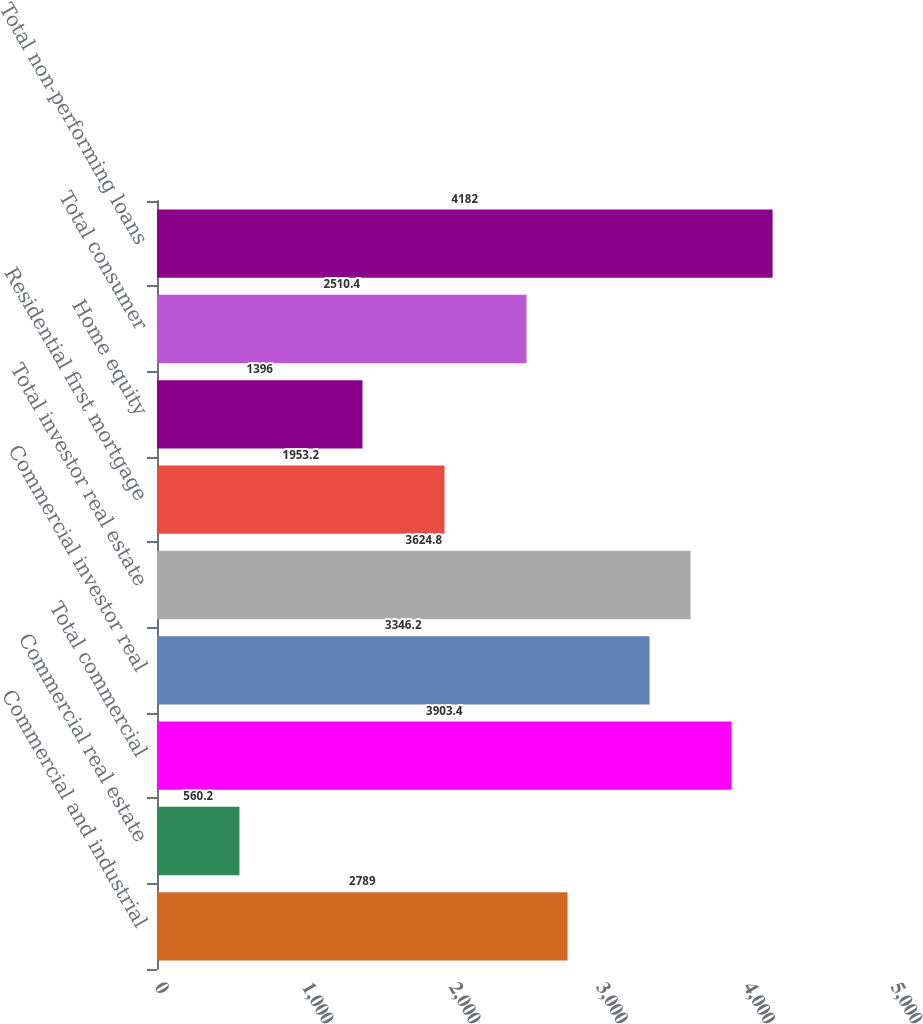Convert chart. <chart><loc_0><loc_0><loc_500><loc_500><bar_chart><fcel>Commercial and industrial<fcel>Commercial real estate<fcel>Total commercial<fcel>Commercial investor real<fcel>Total investor real estate<fcel>Residential first mortgage<fcel>Home equity<fcel>Total consumer<fcel>Total non-performing loans<nl><fcel>2789<fcel>560.2<fcel>3903.4<fcel>3346.2<fcel>3624.8<fcel>1953.2<fcel>1396<fcel>2510.4<fcel>4182<nl></chart> 